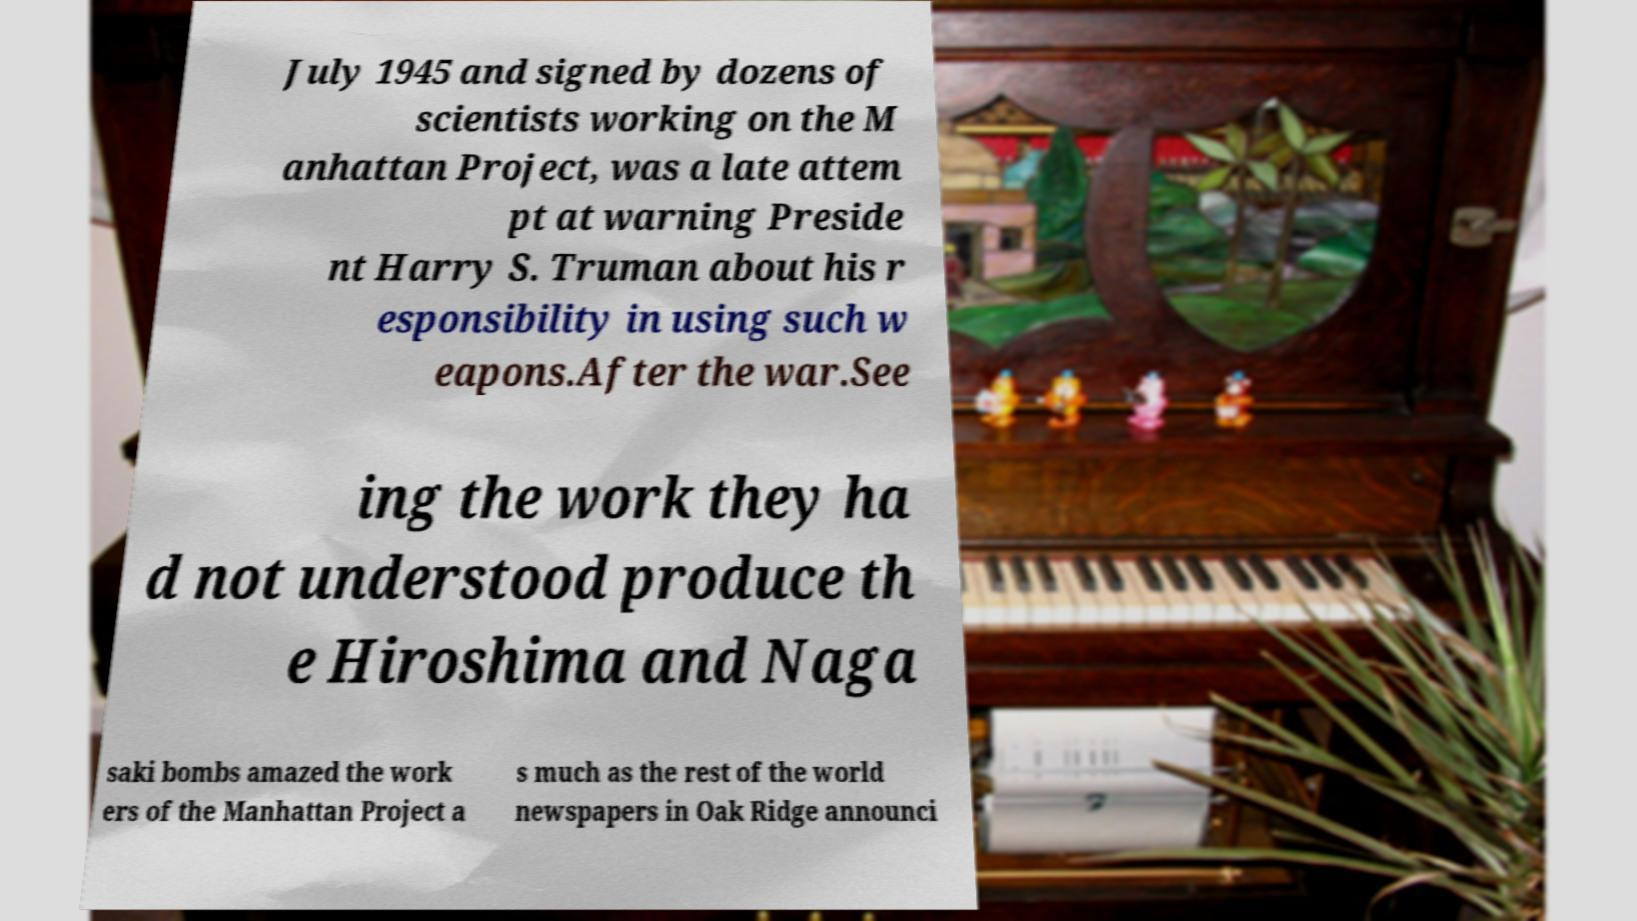Please identify and transcribe the text found in this image. July 1945 and signed by dozens of scientists working on the M anhattan Project, was a late attem pt at warning Preside nt Harry S. Truman about his r esponsibility in using such w eapons.After the war.See ing the work they ha d not understood produce th e Hiroshima and Naga saki bombs amazed the work ers of the Manhattan Project a s much as the rest of the world newspapers in Oak Ridge announci 